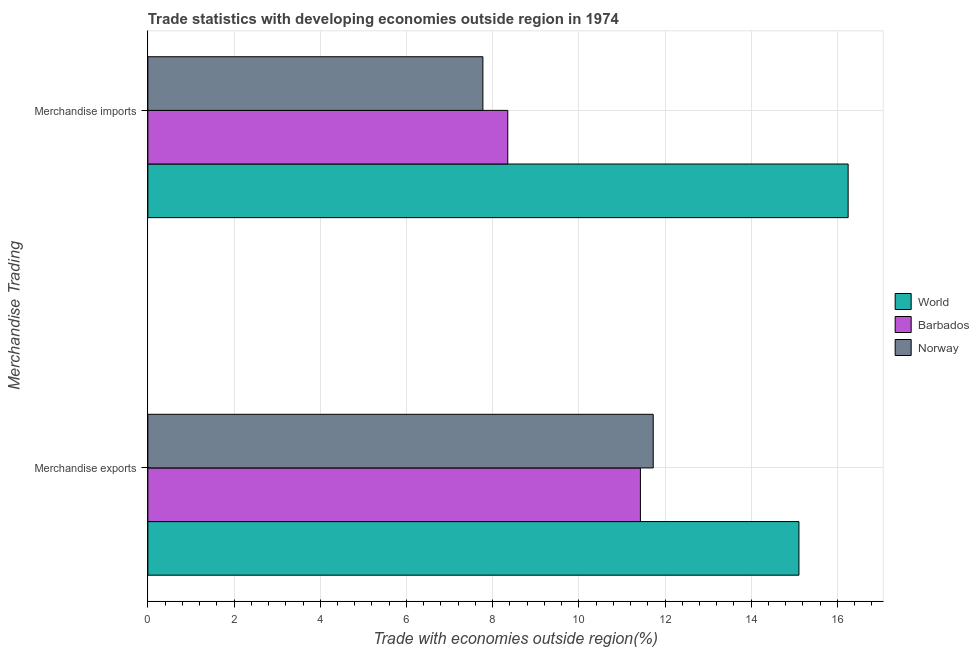How many different coloured bars are there?
Your answer should be very brief. 3. Are the number of bars per tick equal to the number of legend labels?
Offer a very short reply. Yes. How many bars are there on the 1st tick from the bottom?
Your answer should be compact. 3. What is the merchandise exports in Norway?
Provide a short and direct response. 11.73. Across all countries, what is the maximum merchandise imports?
Offer a terse response. 16.25. Across all countries, what is the minimum merchandise imports?
Your answer should be very brief. 7.77. In which country was the merchandise exports maximum?
Keep it short and to the point. World. In which country was the merchandise imports minimum?
Keep it short and to the point. Norway. What is the total merchandise exports in the graph?
Give a very brief answer. 38.26. What is the difference between the merchandise imports in Norway and that in Barbados?
Offer a very short reply. -0.58. What is the difference between the merchandise imports in World and the merchandise exports in Norway?
Give a very brief answer. 4.52. What is the average merchandise imports per country?
Offer a very short reply. 10.79. What is the difference between the merchandise exports and merchandise imports in Barbados?
Make the answer very short. 3.08. In how many countries, is the merchandise imports greater than 3.2 %?
Offer a very short reply. 3. What is the ratio of the merchandise exports in Norway to that in Barbados?
Ensure brevity in your answer.  1.03. Is the merchandise exports in World less than that in Norway?
Keep it short and to the point. No. In how many countries, is the merchandise imports greater than the average merchandise imports taken over all countries?
Offer a very short reply. 1. Are all the bars in the graph horizontal?
Keep it short and to the point. Yes. What is the difference between two consecutive major ticks on the X-axis?
Provide a short and direct response. 2. Are the values on the major ticks of X-axis written in scientific E-notation?
Ensure brevity in your answer.  No. Does the graph contain any zero values?
Your answer should be compact. No. How are the legend labels stacked?
Ensure brevity in your answer.  Vertical. What is the title of the graph?
Your answer should be compact. Trade statistics with developing economies outside region in 1974. What is the label or title of the X-axis?
Keep it short and to the point. Trade with economies outside region(%). What is the label or title of the Y-axis?
Offer a very short reply. Merchandise Trading. What is the Trade with economies outside region(%) of World in Merchandise exports?
Your response must be concise. 15.11. What is the Trade with economies outside region(%) in Barbados in Merchandise exports?
Your answer should be compact. 11.43. What is the Trade with economies outside region(%) of Norway in Merchandise exports?
Your answer should be very brief. 11.73. What is the Trade with economies outside region(%) in World in Merchandise imports?
Provide a short and direct response. 16.25. What is the Trade with economies outside region(%) of Barbados in Merchandise imports?
Provide a succinct answer. 8.35. What is the Trade with economies outside region(%) in Norway in Merchandise imports?
Keep it short and to the point. 7.77. Across all Merchandise Trading, what is the maximum Trade with economies outside region(%) in World?
Provide a short and direct response. 16.25. Across all Merchandise Trading, what is the maximum Trade with economies outside region(%) in Barbados?
Your response must be concise. 11.43. Across all Merchandise Trading, what is the maximum Trade with economies outside region(%) of Norway?
Provide a short and direct response. 11.73. Across all Merchandise Trading, what is the minimum Trade with economies outside region(%) of World?
Provide a succinct answer. 15.11. Across all Merchandise Trading, what is the minimum Trade with economies outside region(%) of Barbados?
Make the answer very short. 8.35. Across all Merchandise Trading, what is the minimum Trade with economies outside region(%) in Norway?
Provide a short and direct response. 7.77. What is the total Trade with economies outside region(%) of World in the graph?
Your answer should be compact. 31.36. What is the total Trade with economies outside region(%) in Barbados in the graph?
Ensure brevity in your answer.  19.78. What is the total Trade with economies outside region(%) in Norway in the graph?
Make the answer very short. 19.5. What is the difference between the Trade with economies outside region(%) of World in Merchandise exports and that in Merchandise imports?
Ensure brevity in your answer.  -1.14. What is the difference between the Trade with economies outside region(%) of Barbados in Merchandise exports and that in Merchandise imports?
Your answer should be very brief. 3.08. What is the difference between the Trade with economies outside region(%) of Norway in Merchandise exports and that in Merchandise imports?
Provide a short and direct response. 3.95. What is the difference between the Trade with economies outside region(%) of World in Merchandise exports and the Trade with economies outside region(%) of Barbados in Merchandise imports?
Give a very brief answer. 6.76. What is the difference between the Trade with economies outside region(%) of World in Merchandise exports and the Trade with economies outside region(%) of Norway in Merchandise imports?
Your answer should be compact. 7.33. What is the difference between the Trade with economies outside region(%) of Barbados in Merchandise exports and the Trade with economies outside region(%) of Norway in Merchandise imports?
Give a very brief answer. 3.65. What is the average Trade with economies outside region(%) of World per Merchandise Trading?
Offer a terse response. 15.68. What is the average Trade with economies outside region(%) in Barbados per Merchandise Trading?
Keep it short and to the point. 9.89. What is the average Trade with economies outside region(%) in Norway per Merchandise Trading?
Your answer should be very brief. 9.75. What is the difference between the Trade with economies outside region(%) of World and Trade with economies outside region(%) of Barbados in Merchandise exports?
Make the answer very short. 3.68. What is the difference between the Trade with economies outside region(%) in World and Trade with economies outside region(%) in Norway in Merchandise exports?
Make the answer very short. 3.38. What is the difference between the Trade with economies outside region(%) in Barbados and Trade with economies outside region(%) in Norway in Merchandise exports?
Offer a terse response. -0.3. What is the difference between the Trade with economies outside region(%) of World and Trade with economies outside region(%) of Barbados in Merchandise imports?
Offer a very short reply. 7.9. What is the difference between the Trade with economies outside region(%) of World and Trade with economies outside region(%) of Norway in Merchandise imports?
Offer a terse response. 8.48. What is the difference between the Trade with economies outside region(%) in Barbados and Trade with economies outside region(%) in Norway in Merchandise imports?
Keep it short and to the point. 0.58. What is the ratio of the Trade with economies outside region(%) of World in Merchandise exports to that in Merchandise imports?
Give a very brief answer. 0.93. What is the ratio of the Trade with economies outside region(%) in Barbados in Merchandise exports to that in Merchandise imports?
Offer a terse response. 1.37. What is the ratio of the Trade with economies outside region(%) of Norway in Merchandise exports to that in Merchandise imports?
Your response must be concise. 1.51. What is the difference between the highest and the second highest Trade with economies outside region(%) of World?
Provide a short and direct response. 1.14. What is the difference between the highest and the second highest Trade with economies outside region(%) of Barbados?
Make the answer very short. 3.08. What is the difference between the highest and the second highest Trade with economies outside region(%) of Norway?
Offer a terse response. 3.95. What is the difference between the highest and the lowest Trade with economies outside region(%) of World?
Make the answer very short. 1.14. What is the difference between the highest and the lowest Trade with economies outside region(%) in Barbados?
Offer a very short reply. 3.08. What is the difference between the highest and the lowest Trade with economies outside region(%) of Norway?
Give a very brief answer. 3.95. 